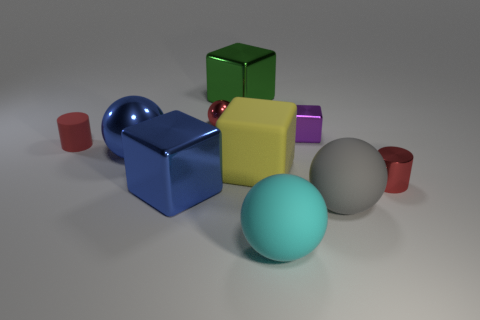Subtract all purple cubes. How many cubes are left? 3 Subtract 2 cubes. How many cubes are left? 2 Subtract all cylinders. How many objects are left? 8 Add 7 small red shiny spheres. How many small red shiny spheres exist? 8 Subtract all green blocks. How many blocks are left? 3 Subtract 0 purple cylinders. How many objects are left? 10 Subtract all brown cubes. Subtract all brown balls. How many cubes are left? 4 Subtract all big matte objects. Subtract all big green things. How many objects are left? 6 Add 6 gray spheres. How many gray spheres are left? 7 